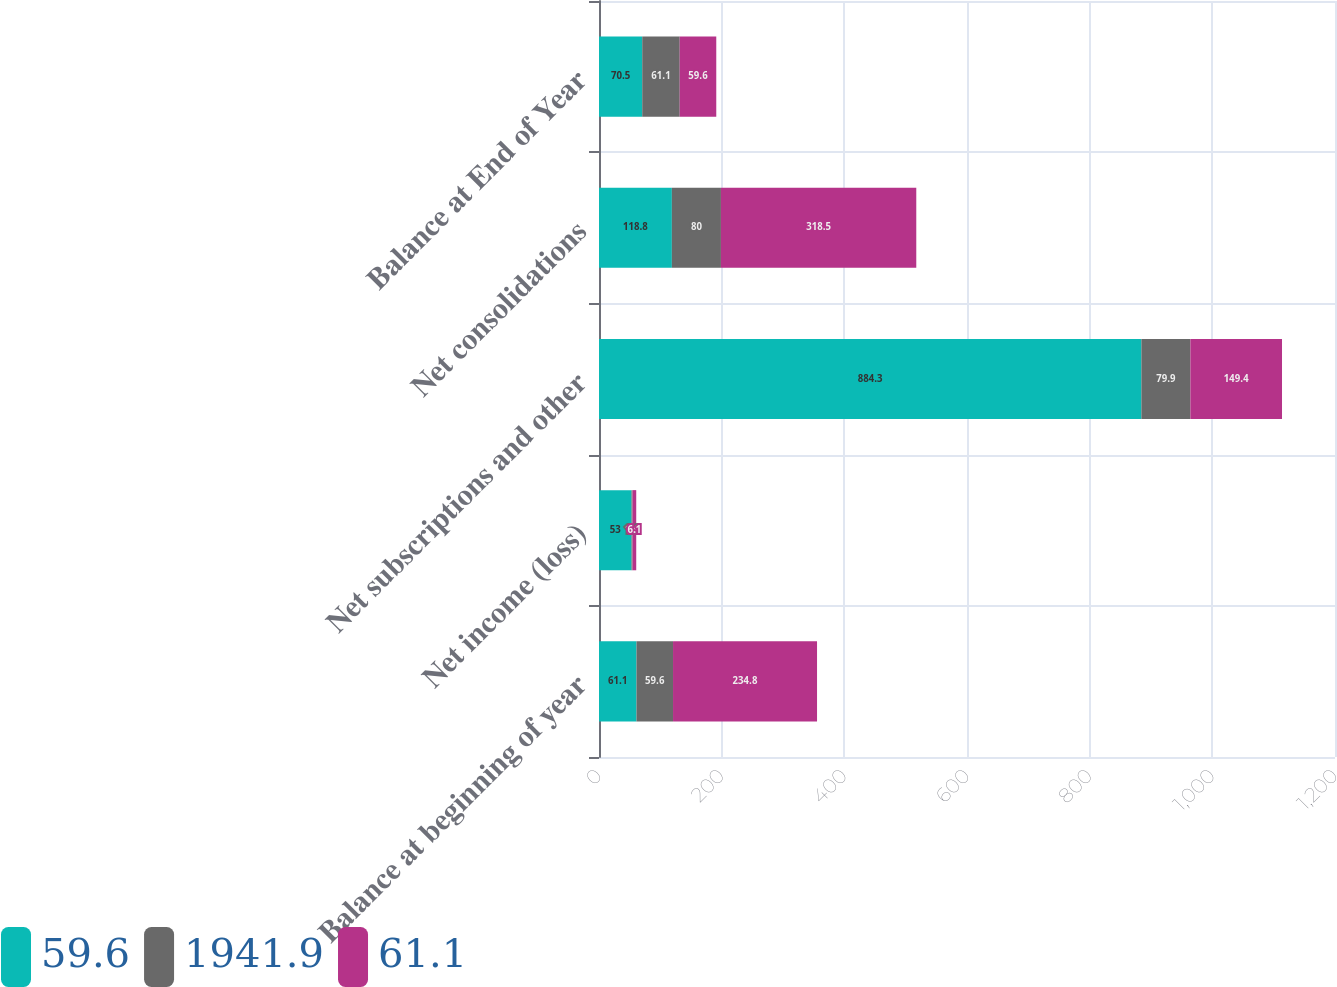Convert chart to OTSL. <chart><loc_0><loc_0><loc_500><loc_500><stacked_bar_chart><ecel><fcel>Balance at beginning of year<fcel>Net income (loss)<fcel>Net subscriptions and other<fcel>Net consolidations<fcel>Balance at End of Year<nl><fcel>59.6<fcel>61.1<fcel>53<fcel>884.3<fcel>118.8<fcel>70.5<nl><fcel>1941.9<fcel>59.6<fcel>1.6<fcel>79.9<fcel>80<fcel>61.1<nl><fcel>61.1<fcel>234.8<fcel>6.1<fcel>149.4<fcel>318.5<fcel>59.6<nl></chart> 